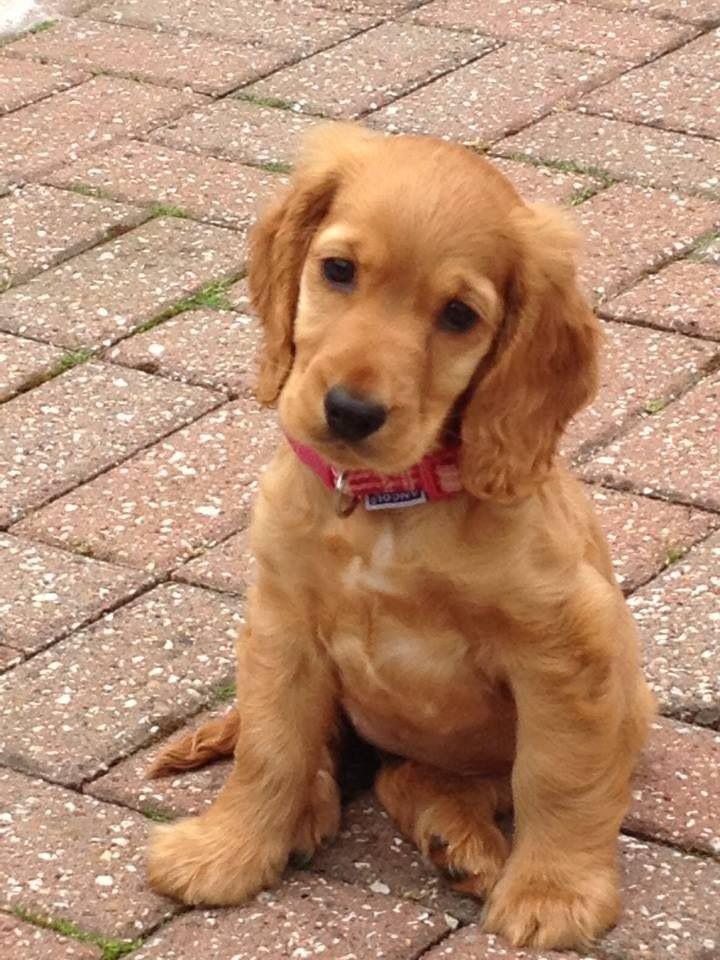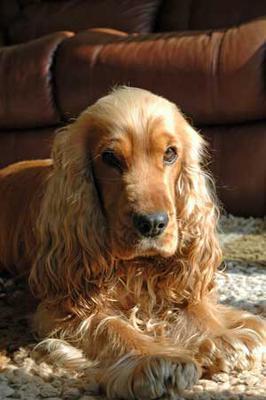The first image is the image on the left, the second image is the image on the right. Analyze the images presented: Is the assertion "The sky can be seen in the background of one of the images." valid? Answer yes or no. No. 